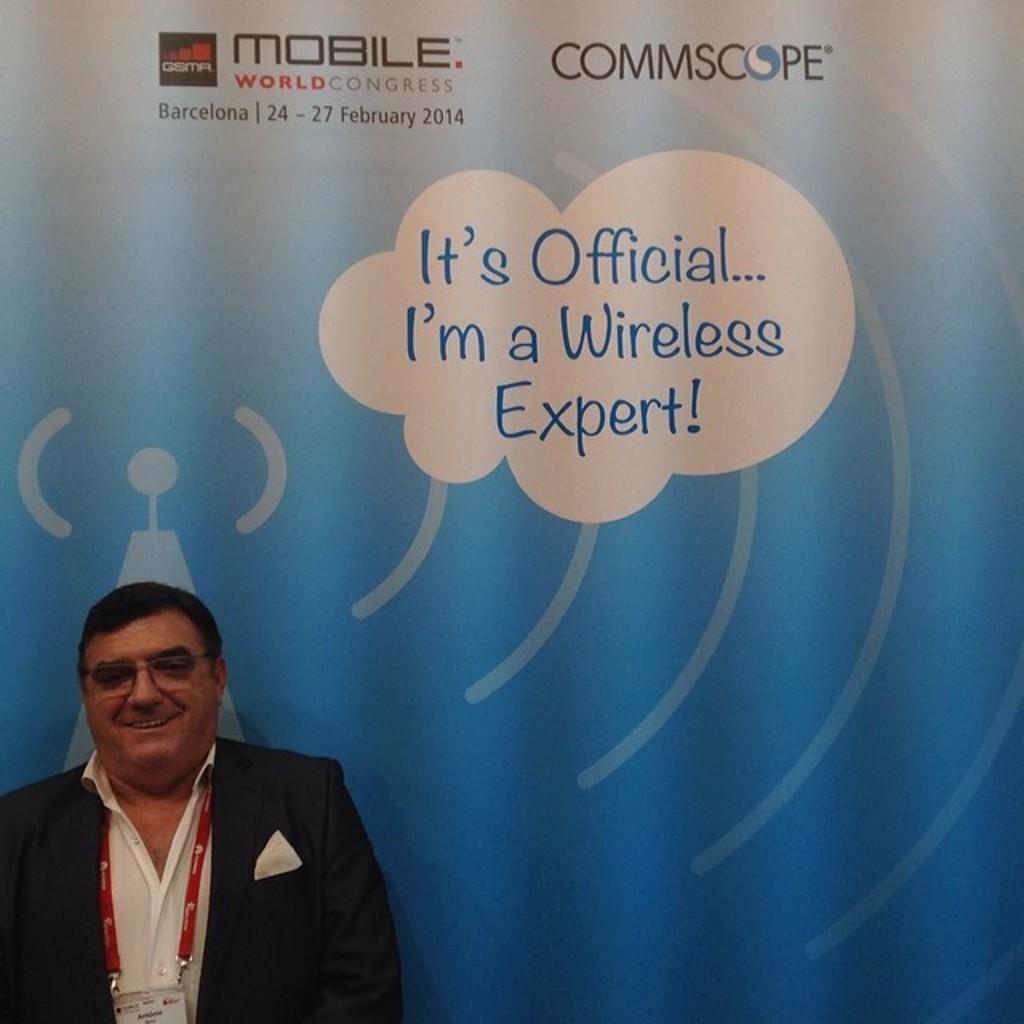What type of expert is he?
Give a very brief answer. Wireless. 